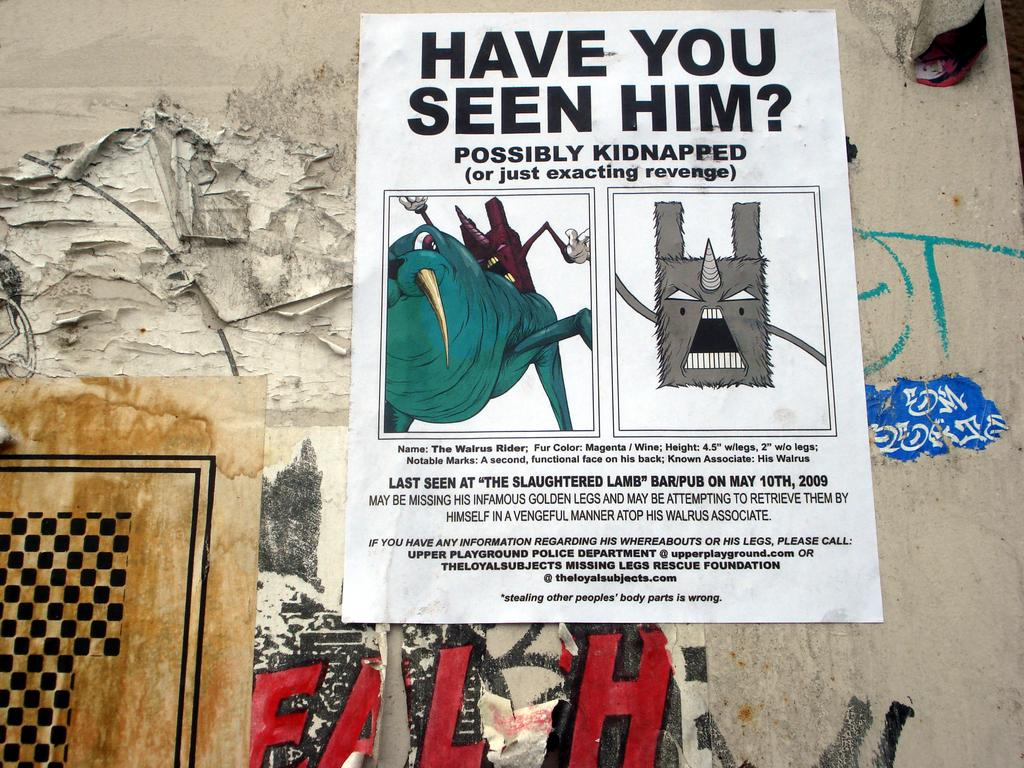What is present on the wall in the image? There are posters stuck to the wall in the image. Can you describe the posters on the wall? Unfortunately, the provided facts do not give any details about the posters themselves. How many posters are on the wall? The number of posters on the wall cannot be determined from the provided facts. What type of breakfast is the queen eating in the image? There is no queen or breakfast present in the image; it only features a wall with posters on it. 